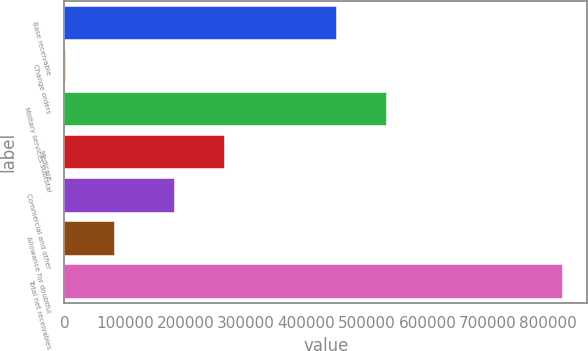<chart> <loc_0><loc_0><loc_500><loc_500><bar_chart><fcel>Base receivable<fcel>Change orders<fcel>Military services subtotal<fcel>Medicare<fcel>Commercial and other<fcel>Allowance for doubtful<fcel>Total net receivables<nl><fcel>451248<fcel>2024<fcel>533408<fcel>265284<fcel>183124<fcel>84183.6<fcel>823620<nl></chart> 